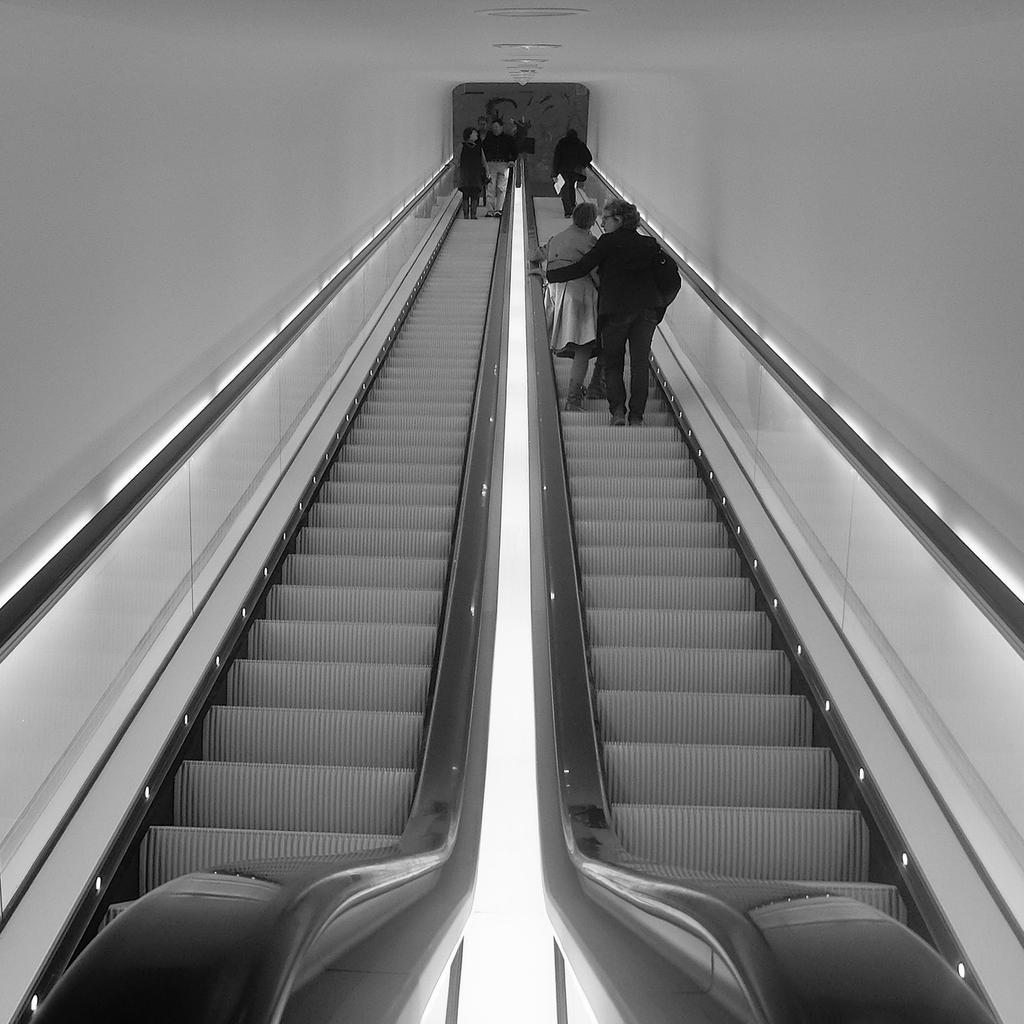Could you give a brief overview of what you see in this image? In this image we can see the persons standing on the escalator and at the sides we can see the wall. In front of the escalator we can see an object. 